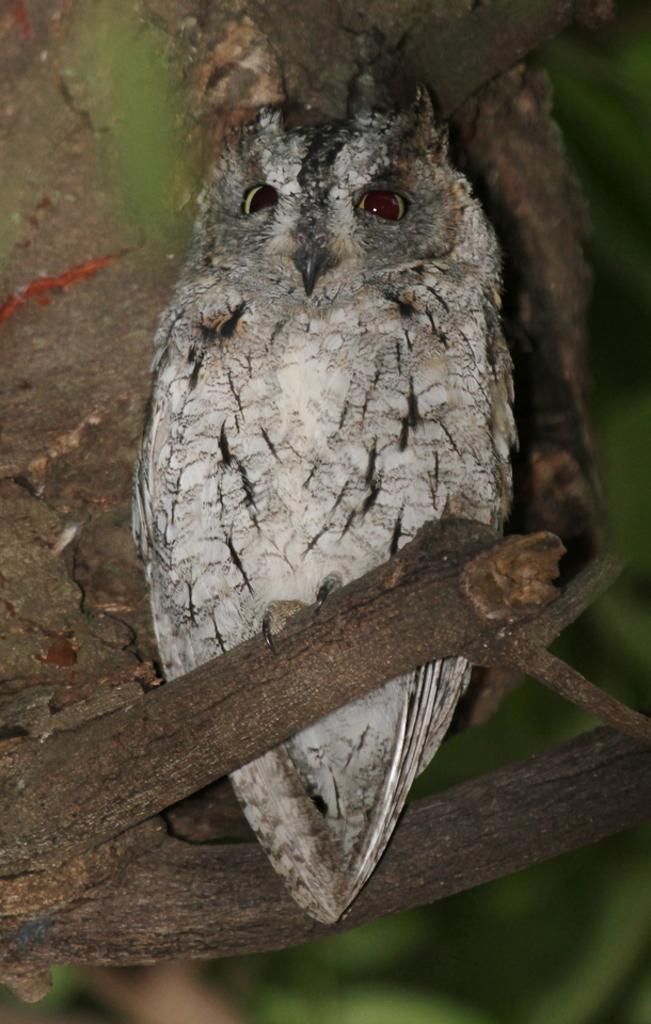How would you summarize this image in a sentence or two? In this image I can see a white colour owl in the front. In the background I can see green colour and I can see this image is little bit blurry in the background. In the front I can see sticks. 